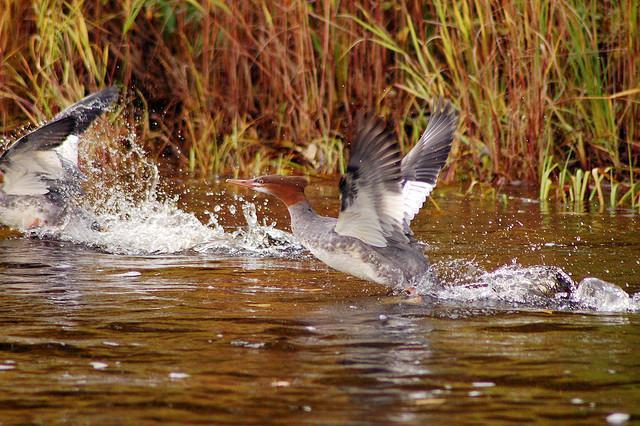How many bird heads are in the scene?
Give a very brief answer. 1. How many birds can be seen?
Give a very brief answer. 2. 